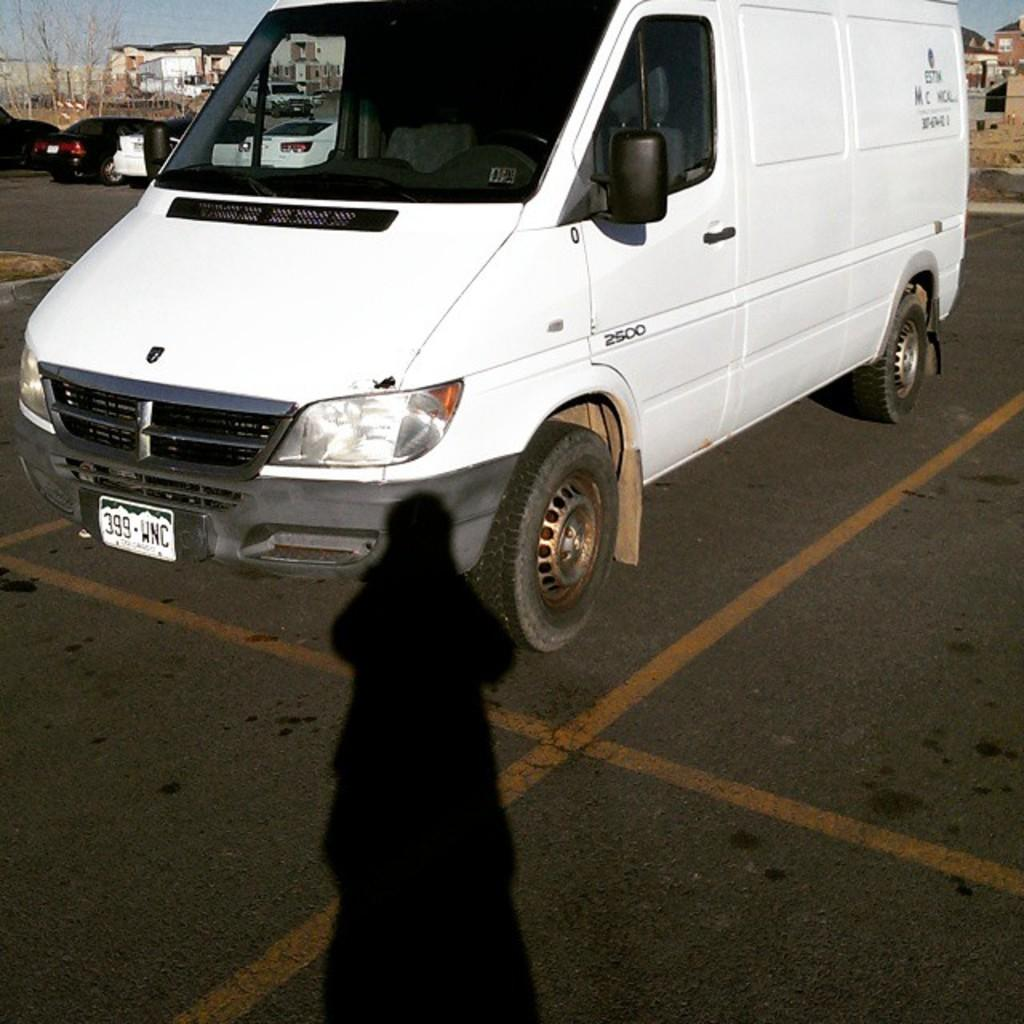<image>
Present a compact description of the photo's key features. A white van is parked with the licence plate 399 WNC 